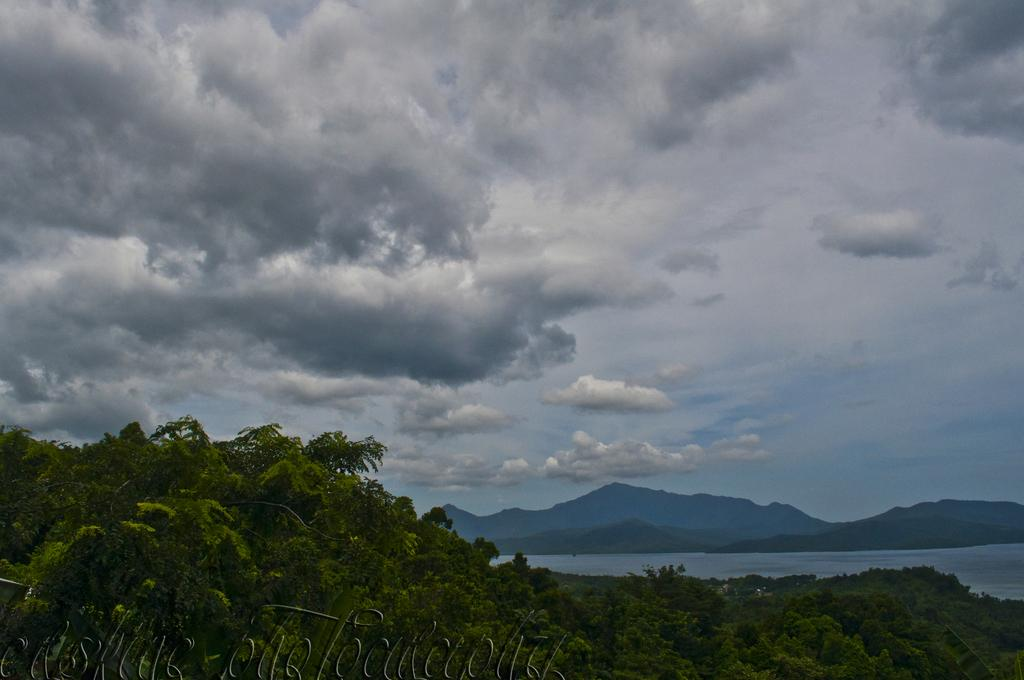What type of vegetation is at the bottom of the image? There are trees at the bottom of the image. What natural feature can be seen in the background of the image? There is a river in the background of the image. What type of landscape is visible in the background of the image? There are hills in the background of the image. What is visible above the landscape in the image? The sky is visible in the background of the image. Where is the pot located in the image? There is no pot present in the image. What type of cart can be seen in the image? There is no cart present in the image. 